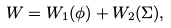Convert formula to latex. <formula><loc_0><loc_0><loc_500><loc_500>W = W _ { 1 } ( \phi ) + W _ { 2 } ( \Sigma ) ,</formula> 